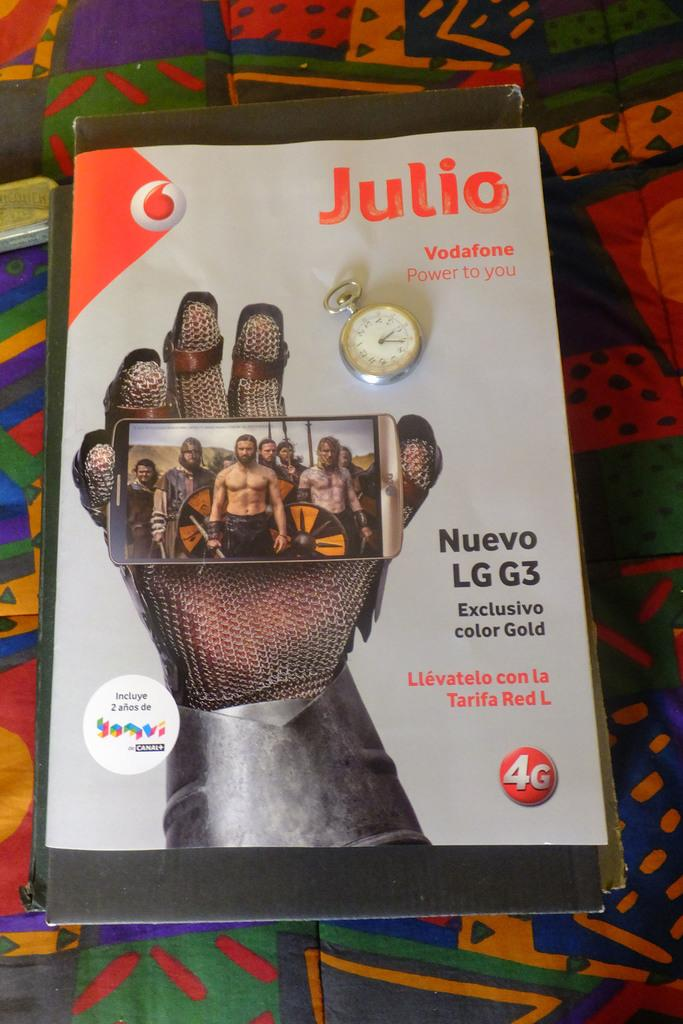<image>
Create a compact narrative representing the image presented. Magazine cover which has the word "Julio" on the top right. 